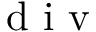<formula> <loc_0><loc_0><loc_500><loc_500>d i v</formula> 